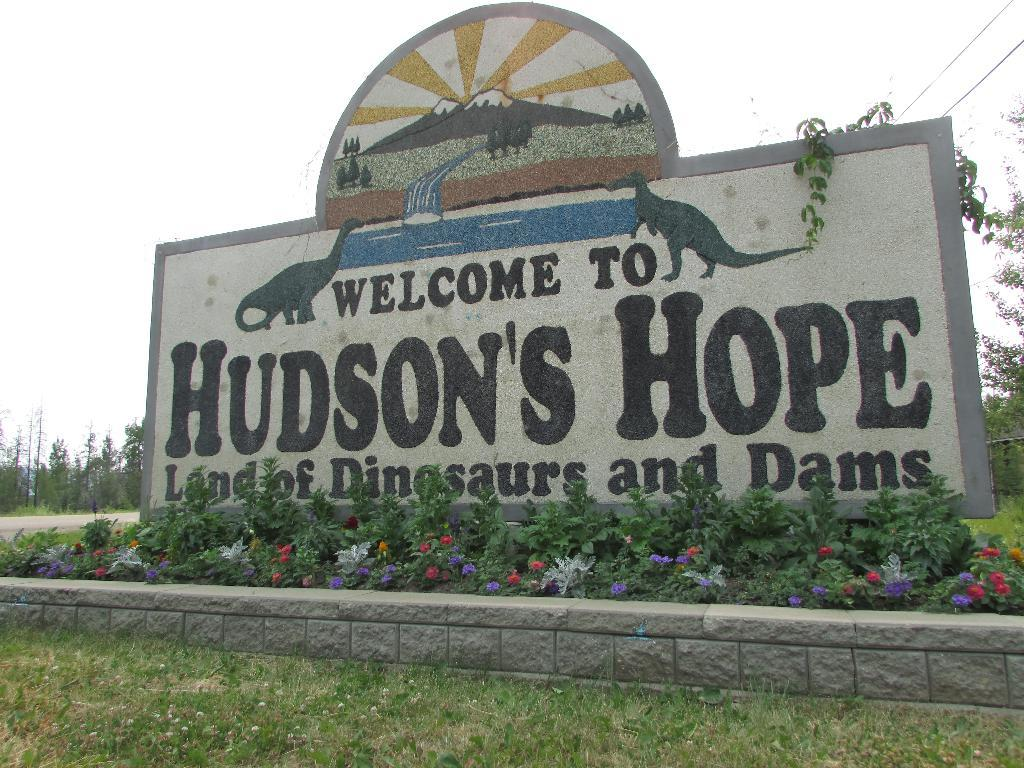What type of structure is visible in the image? There is a stone wall in the image. What can be seen on the stone wall? Something is written on the stone wall. What type of vegetation is present in the image? There is green grass and flower plants in the image. What can be seen in the background of the image? There are trees in the background of the image. What type of station does the minister use in the image? There is no minister or station present in the image. How is the measure of the grass determined in the image? The image does not provide any information about the measure of the grass. 